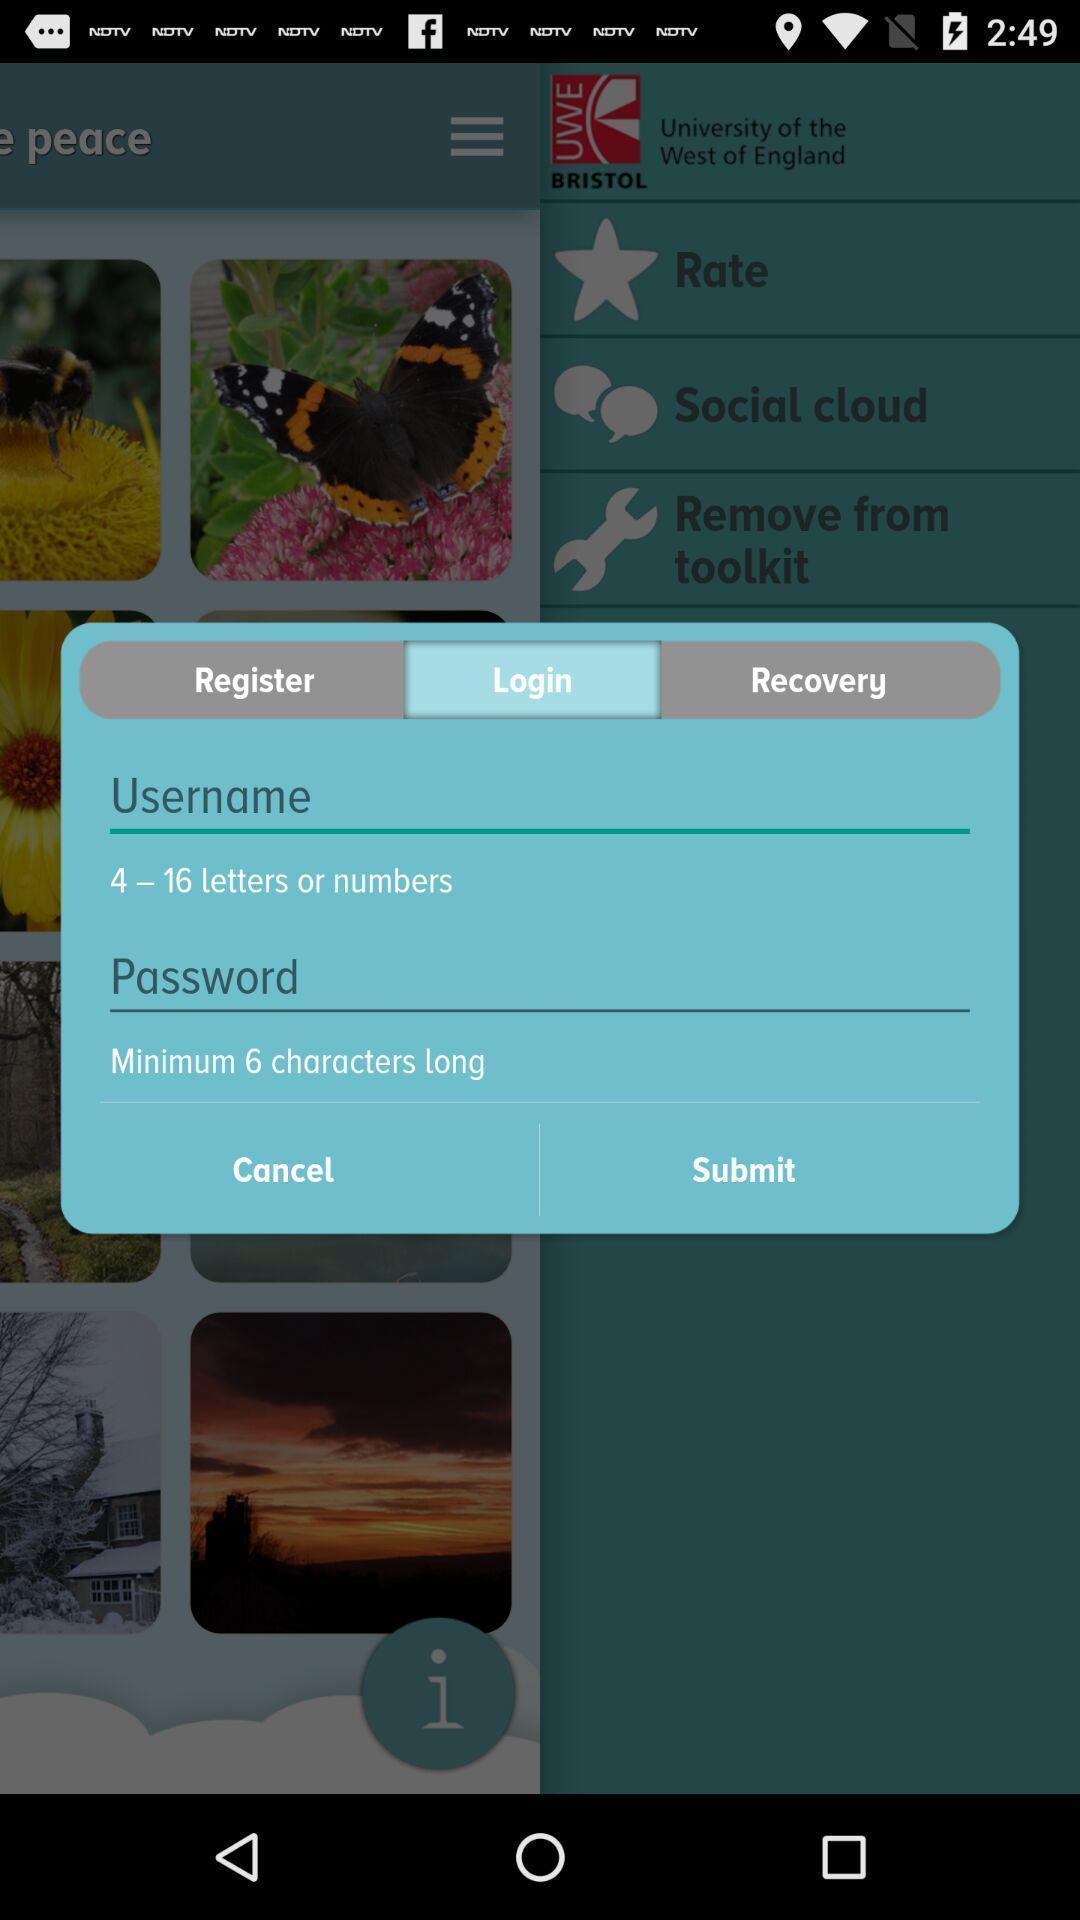Provide a detailed account of this screenshot. Screen displaying the login page. 